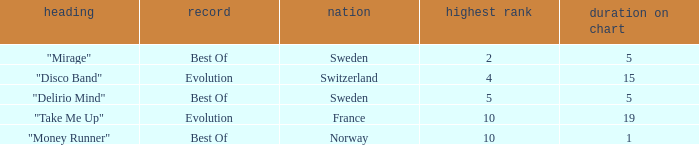What is the most weeks on chart when the peak position is less than 5 and from sweden? 5.0. 